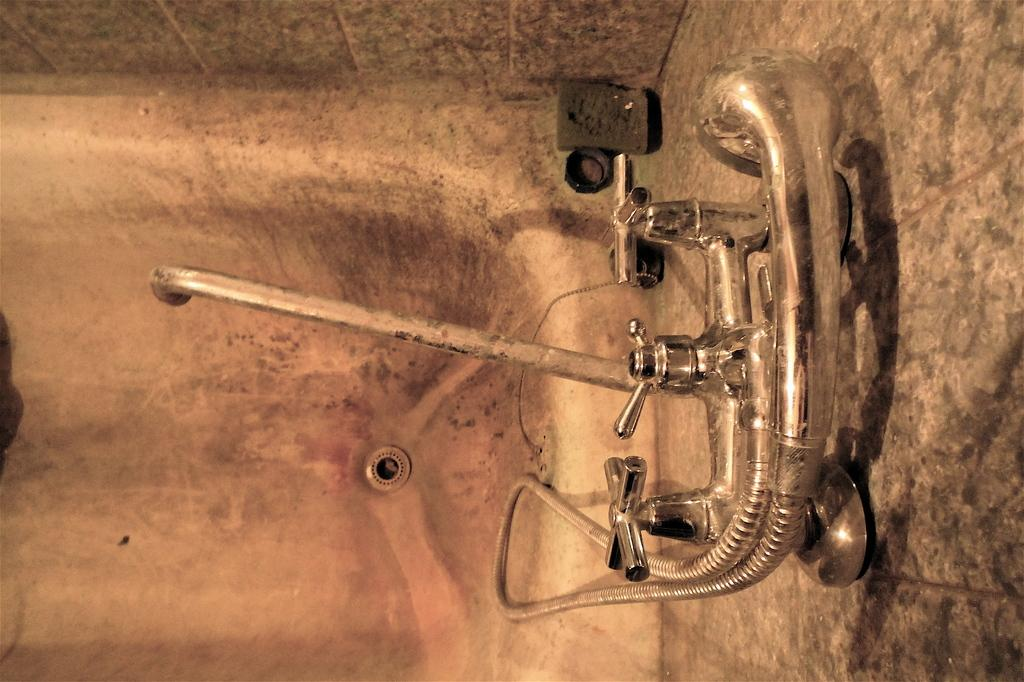What is located in the foreground of the image? There is a bathtub, a tap, and a shower in the foreground of the image. Can you describe the elements in the foreground of the image? The foreground of the image includes a bathtub, a tap, and a shower. What is visible in the background of the image? There is a wall visible in the image. What type of cake is being read in the library in the image? There is no library or cake present in the image. What is the title of the book that the cake is reading in the image? There is no book or cake present in the image. 